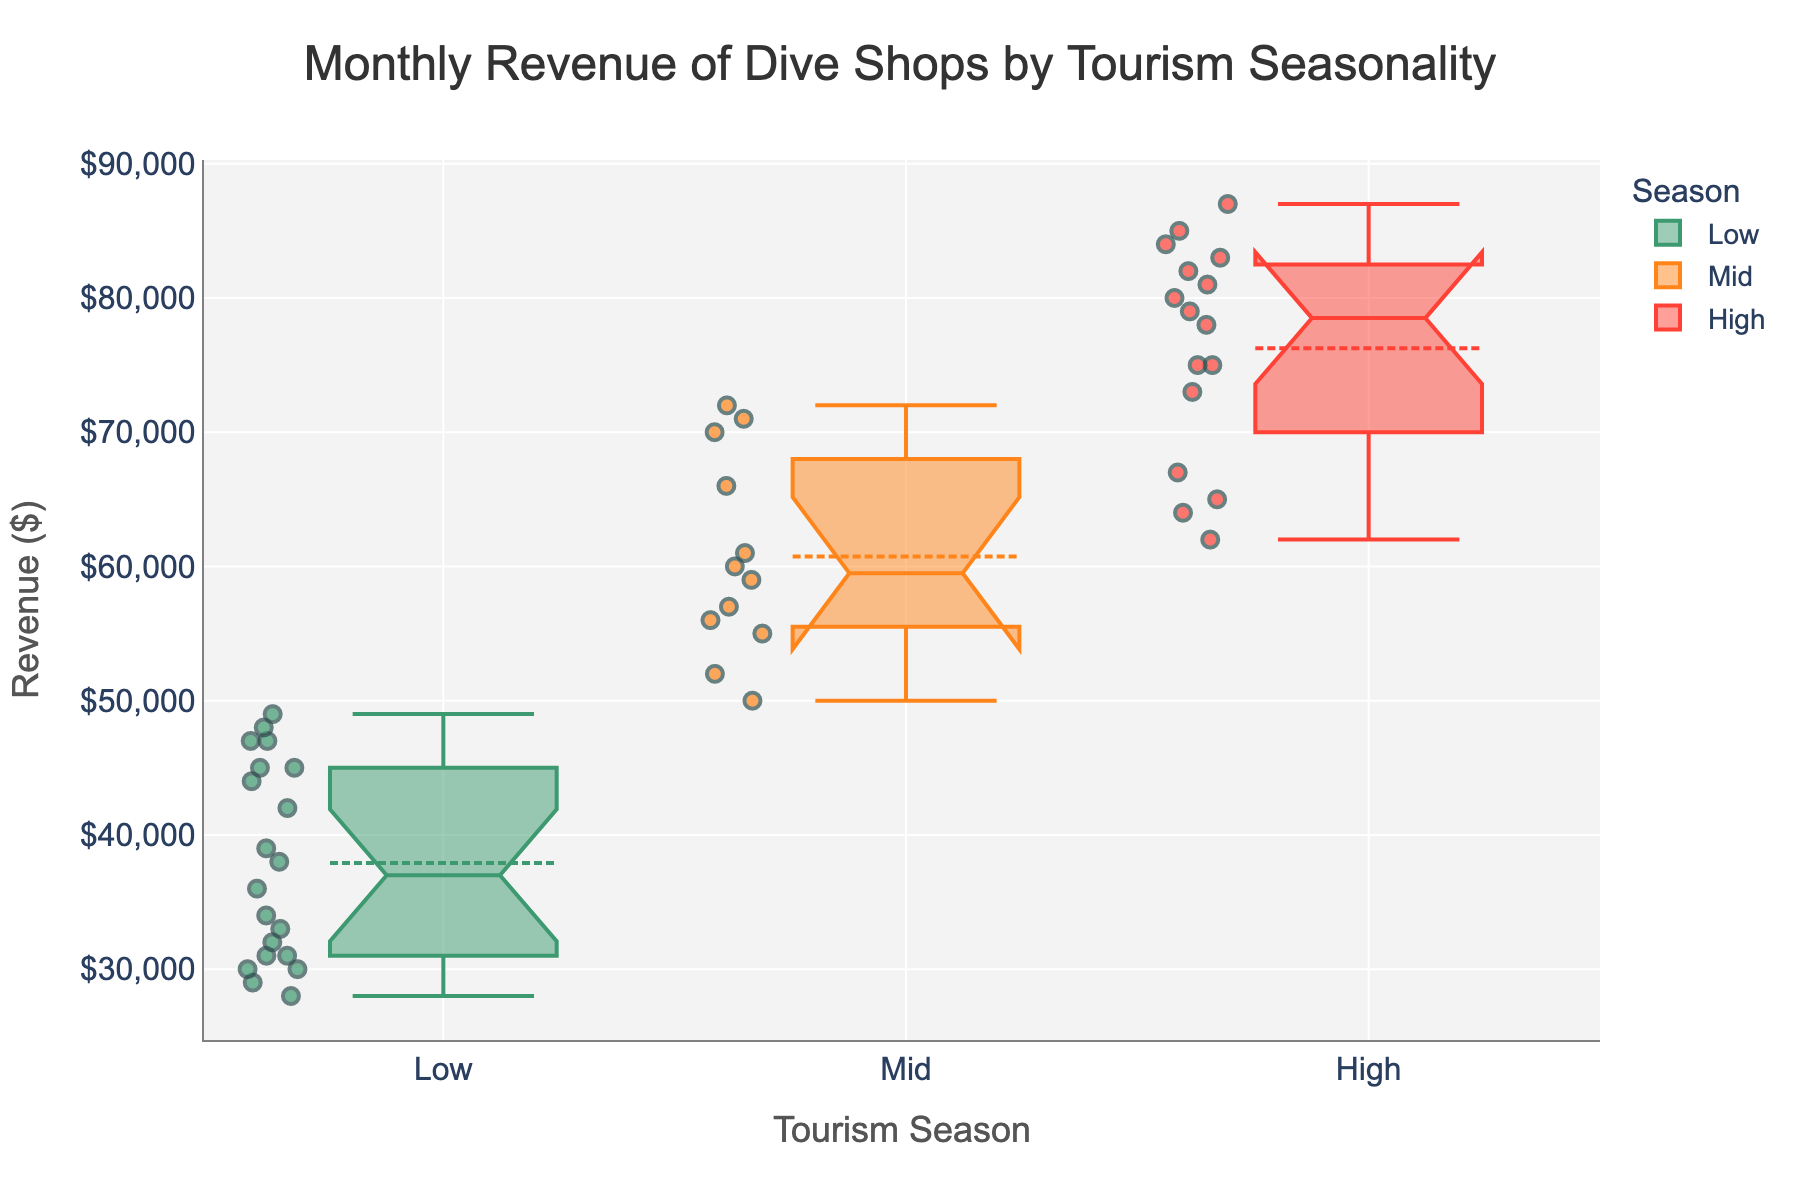What are the tourism seasons shown in the plot? The tourism seasons are visible on the x-axis of the plot, which shows the categories used for grouping the data. These categories are 'Low', 'Mid', and 'High'.
Answer: Low, Mid, High Which season has the highest median revenue? To find the season with the highest median revenue, look at the notches in the box plots which represent the median values. The 'High' season box plot will have the highest notch compared to the 'Mid' and 'Low' seasons.
Answer: High What is the range of the revenues in the 'Mid' season? The range can be determined by looking at the top (maximum) and bottom (minimum) whiskers of the 'Mid' season box plot.
Answer: \$50,000 to \$72,000 Which season has the most data points plotted? Count the number of points (dots) present within each season's box plot.
Answer: High In which season does the revenue vary the most? The season with the widest interquartile range (the middle 50% of the data) shows the most variation. This can be determined by observing the boxes in the box plots, and noticing the 'High' season has the widest box.
Answer: High What is the median revenue during the 'Low' season? The median revenue in the 'Low' season is shown by the notch in the 'Low' season box plot.
Answer: \$39,000 Compare the median revenues of the 'Mid' and 'High' seasons. Which one is higher? Look at the notches of the box plots for 'Mid' and 'High' seasons to find the median values and compare them. The 'High' season’s median is higher.
Answer: High Is there an overlap in the interquartile ranges of 'Low' and 'Mid' seasons? Overlap can be determined by checking if the shaded boxes of 'Low' and 'Mid' seasons have any common area.
Answer: No What revenue value does the 75th percentile represent in the 'High' season? The 75th percentile is the top edge of the box in the 'High' season's box plot.
Answer: Approximately \$82,500 